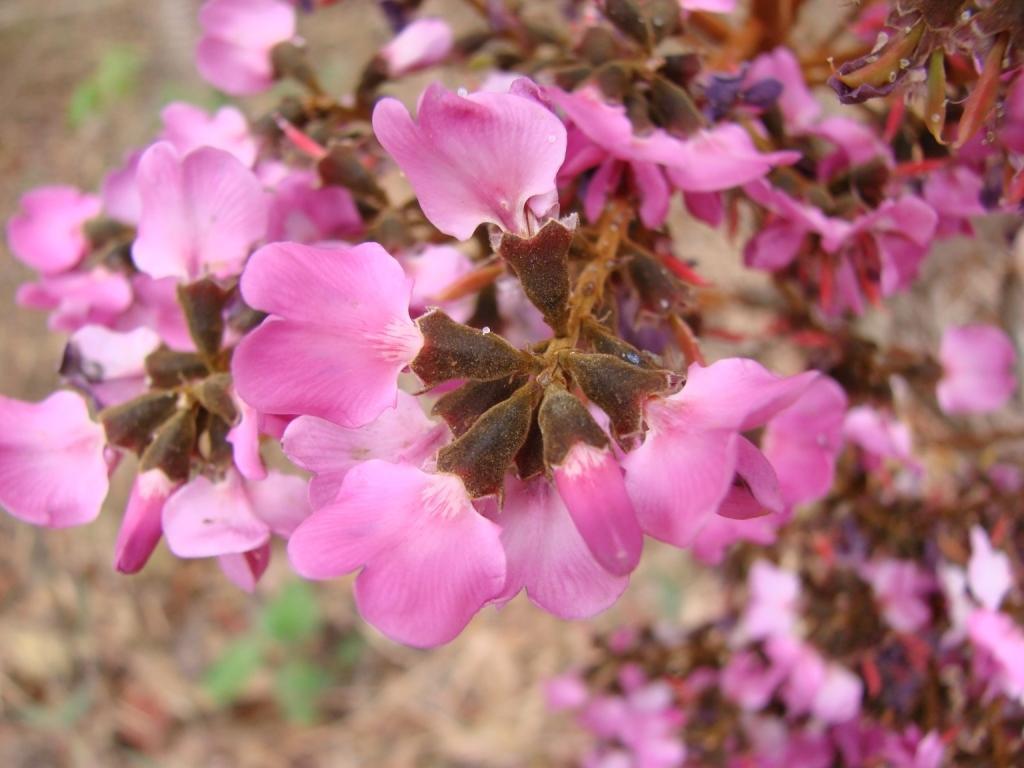Can you describe this image briefly? In this image we can see flowers. The background of the image is blur. 